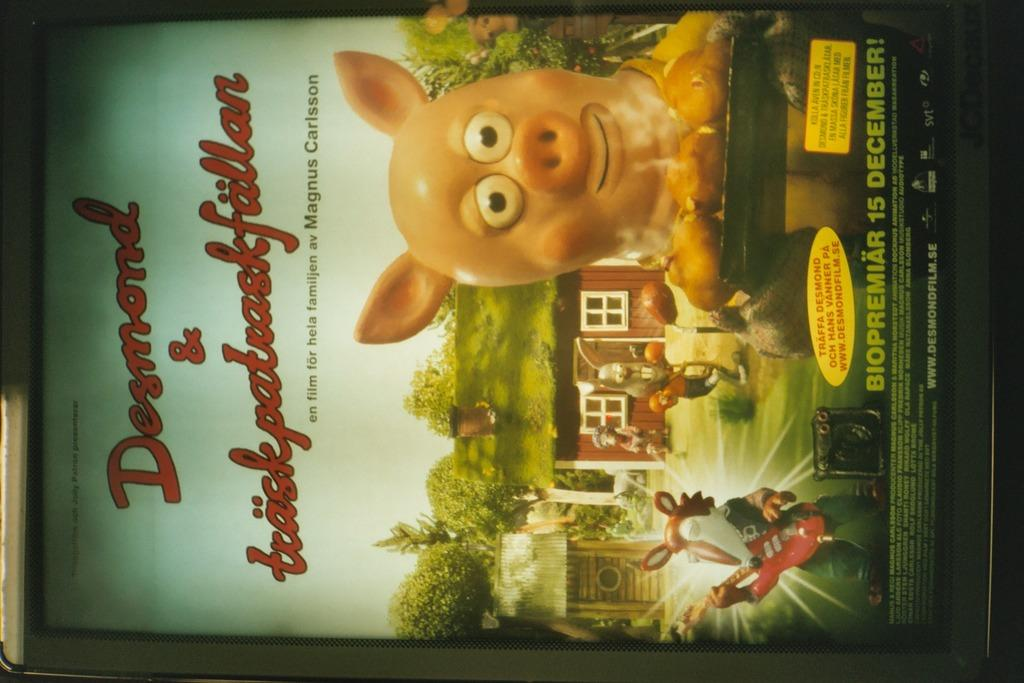What is a notable characteristic of the image? The image is edited. What type of animals can be seen in the image? There are pigs in the image. What type of structures are present in the image? There are houses in the image. What type of vegetation is visible in the image? There are trees in the image. What is visible at the top of the image? The sky is visible at the top of the image. How many flies can be seen on the houses in the image? There are no flies present in the image. What type of reptile can be seen interacting with the pigs in the image? There are no reptiles present in the image. 